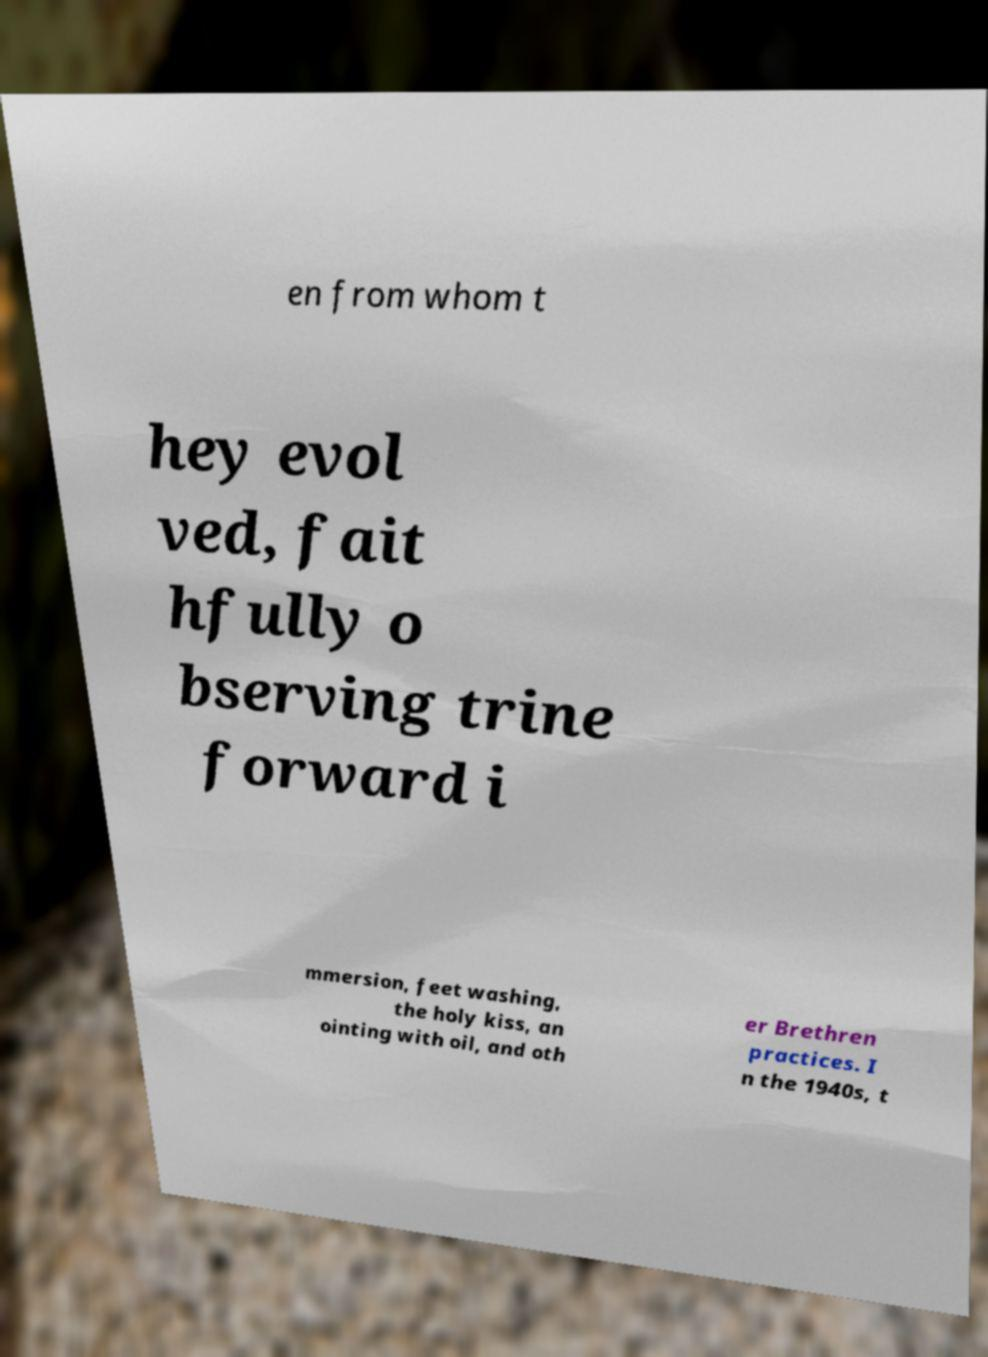What messages or text are displayed in this image? I need them in a readable, typed format. en from whom t hey evol ved, fait hfully o bserving trine forward i mmersion, feet washing, the holy kiss, an ointing with oil, and oth er Brethren practices. I n the 1940s, t 